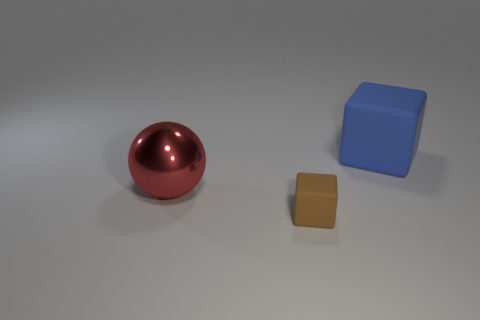Subtract all spheres. How many objects are left? 2 Add 1 tiny brown matte objects. How many objects exist? 4 Subtract 1 balls. How many balls are left? 0 Subtract 0 green spheres. How many objects are left? 3 Subtract all yellow balls. Subtract all brown cubes. How many balls are left? 1 Subtract all blue cylinders. How many blue blocks are left? 1 Subtract all tiny matte things. Subtract all large gray shiny things. How many objects are left? 2 Add 1 red shiny things. How many red shiny things are left? 2 Add 3 red metal things. How many red metal things exist? 4 